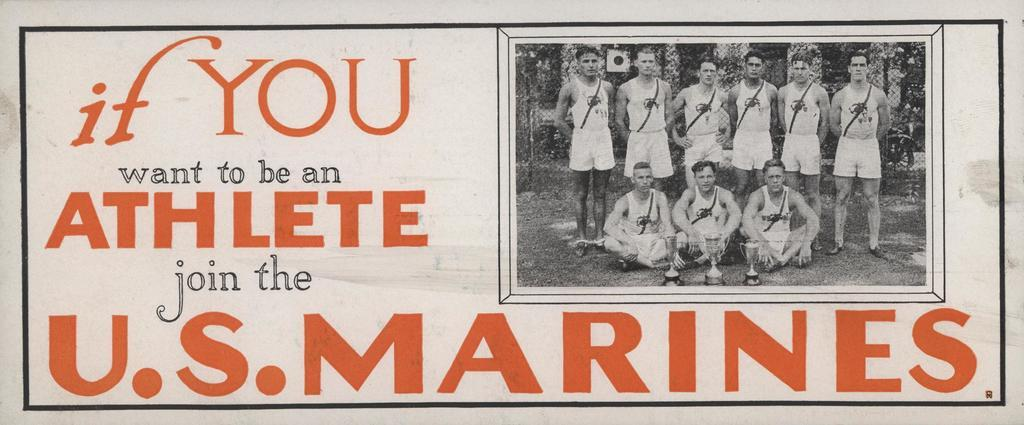<image>
Describe the image concisely. A poster of a group of players posing with the title "If you want to be an athlete join the US Marines" 